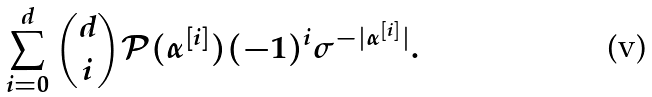<formula> <loc_0><loc_0><loc_500><loc_500>\sum _ { i = 0 } ^ { d } { d \choose i } { \mathcal { P } } ( \alpha ^ { [ i ] } ) ( - 1 ) ^ { i } \sigma ^ { - | \alpha ^ { [ i ] } | } .</formula> 